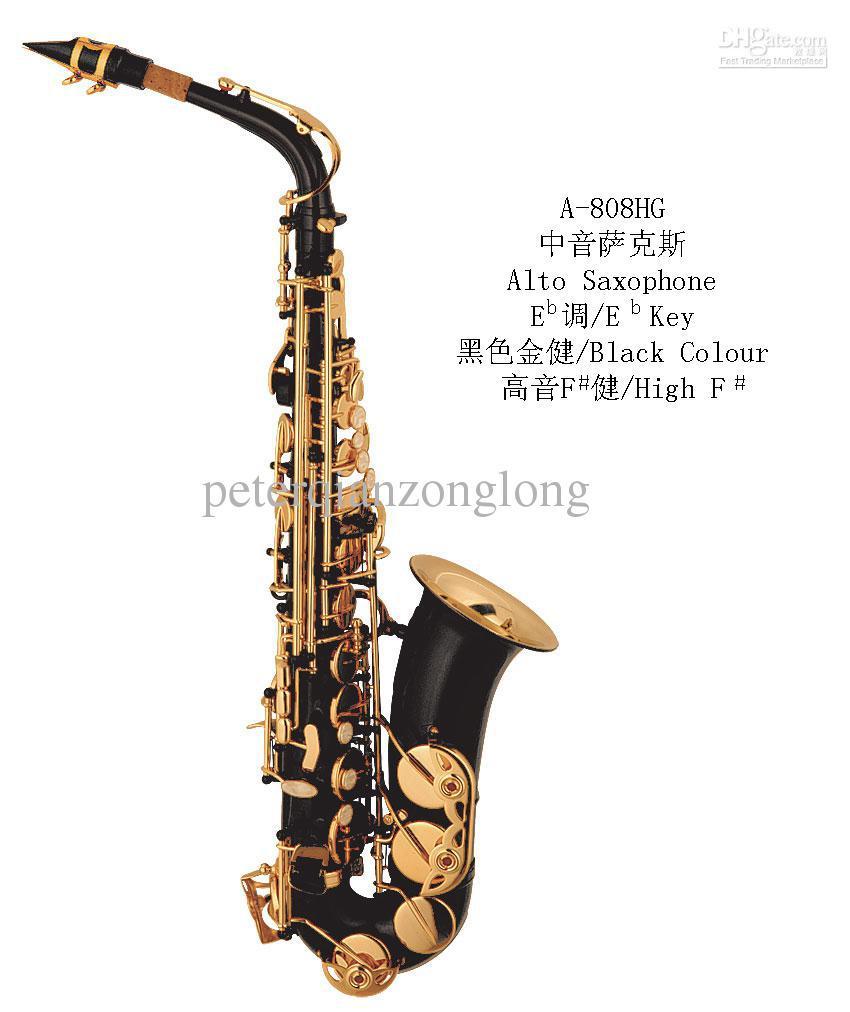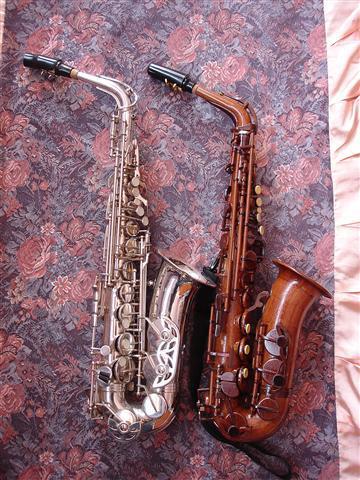The first image is the image on the left, the second image is the image on the right. For the images shown, is this caption "There is exactly one instrument against a white background in the image on the left." true? Answer yes or no. Yes. 